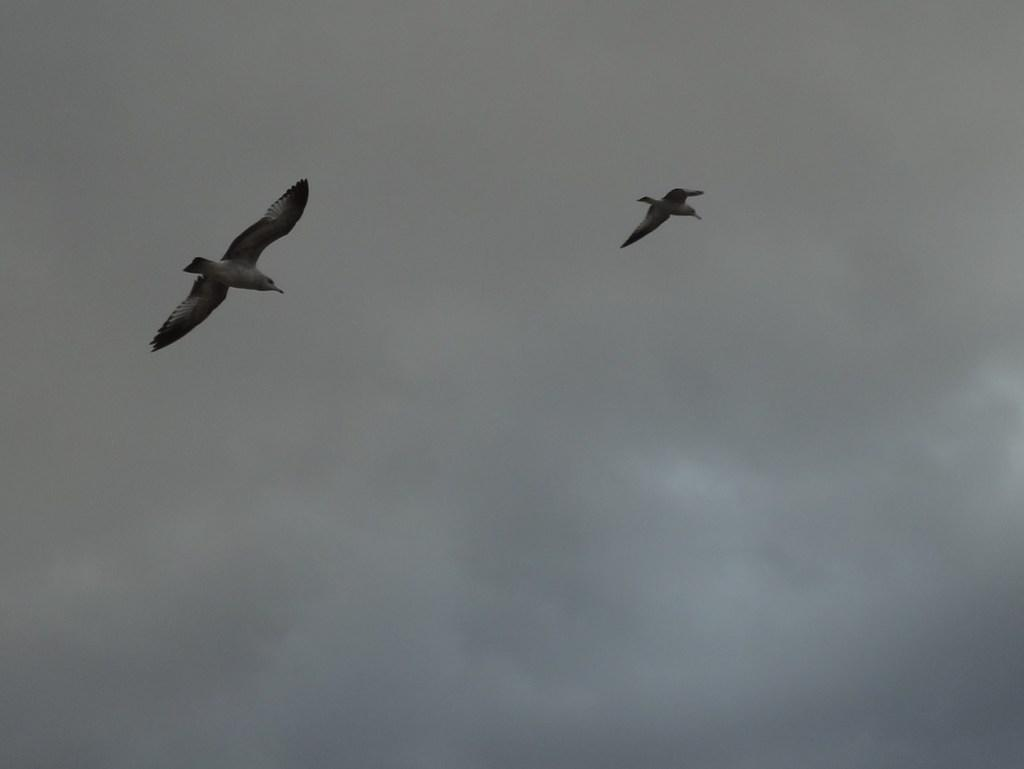How many birds can be seen in the image? There are two birds in the image. What are the birds doing in the image? The birds are flying in the air. What can be seen in the background of the image? There are clouds in the sky in the background of the image. What color is the grape that the birds are holding in the image? There are no grapes present in the image, and the birds are not holding anything. 